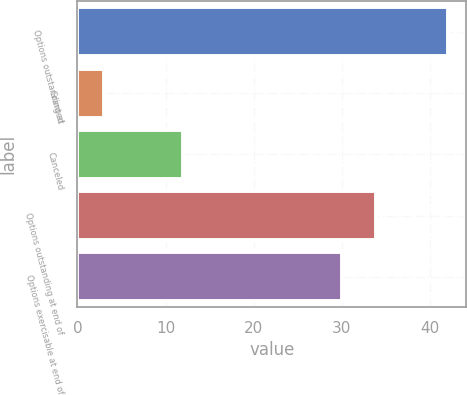<chart> <loc_0><loc_0><loc_500><loc_500><bar_chart><fcel>Options outstanding at<fcel>Granted<fcel>Canceled<fcel>Options outstanding at end of<fcel>Options exercisable at end of<nl><fcel>42<fcel>3<fcel>12<fcel>33.9<fcel>30<nl></chart> 